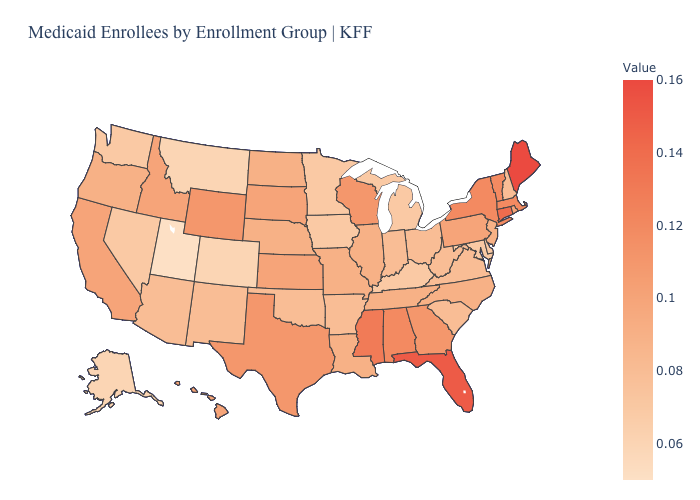Among the states that border South Dakota , does Wyoming have the highest value?
Be succinct. Yes. Does the map have missing data?
Give a very brief answer. No. Which states have the lowest value in the USA?
Be succinct. Utah. Which states have the highest value in the USA?
Write a very short answer. Maine. Which states hav the highest value in the West?
Quick response, please. Wyoming. Among the states that border New Hampshire , does Maine have the lowest value?
Write a very short answer. No. 